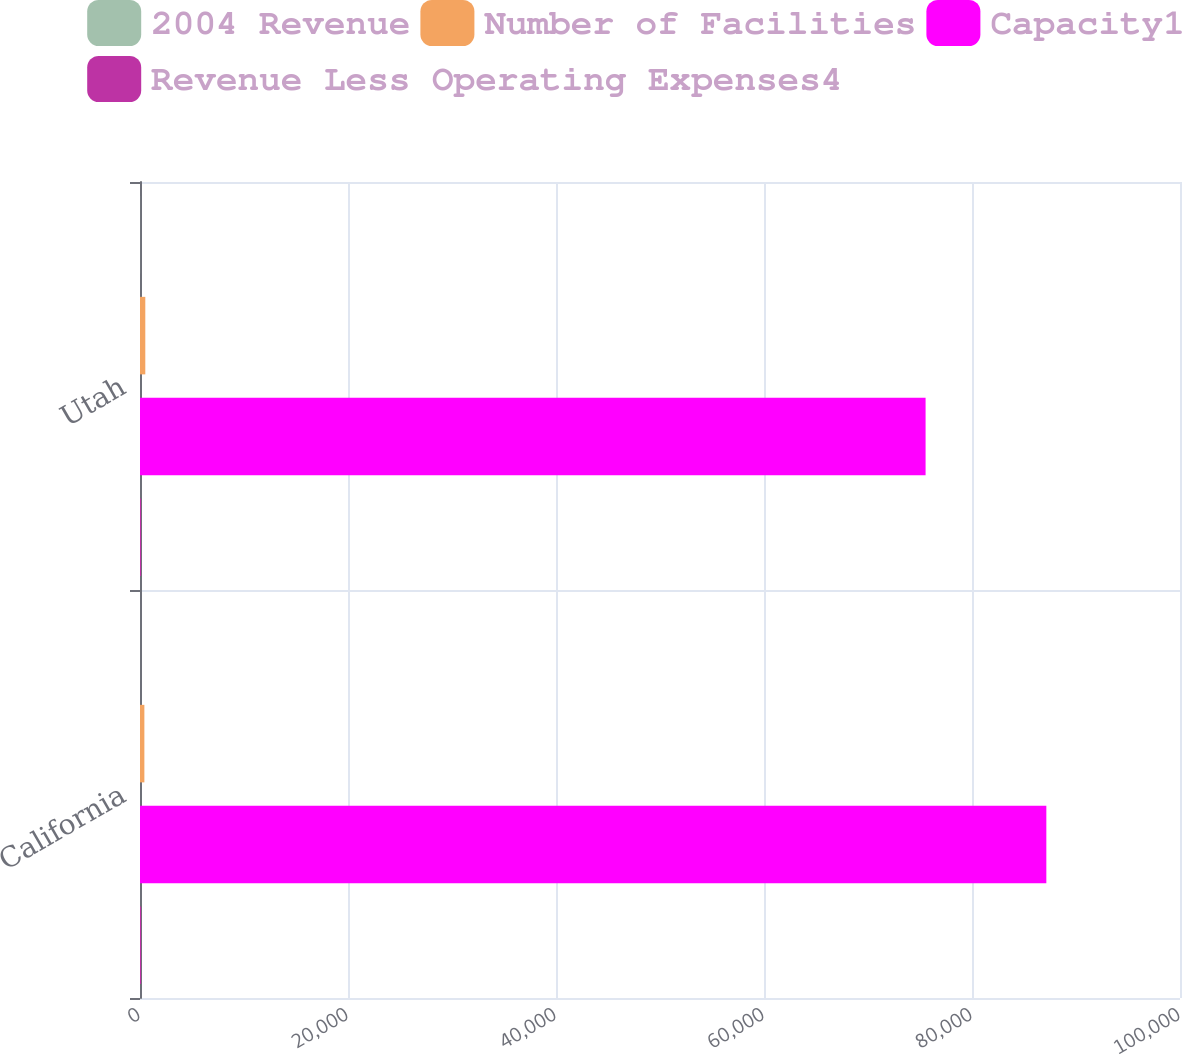Convert chart. <chart><loc_0><loc_0><loc_500><loc_500><stacked_bar_chart><ecel><fcel>California<fcel>Utah<nl><fcel>2004 Revenue<fcel>3<fcel>8<nl><fcel>Number of Facilities<fcel>421<fcel>510<nl><fcel>Capacity1<fcel>87148<fcel>75537<nl><fcel>Revenue Less Operating Expenses4<fcel>100<fcel>100<nl></chart> 